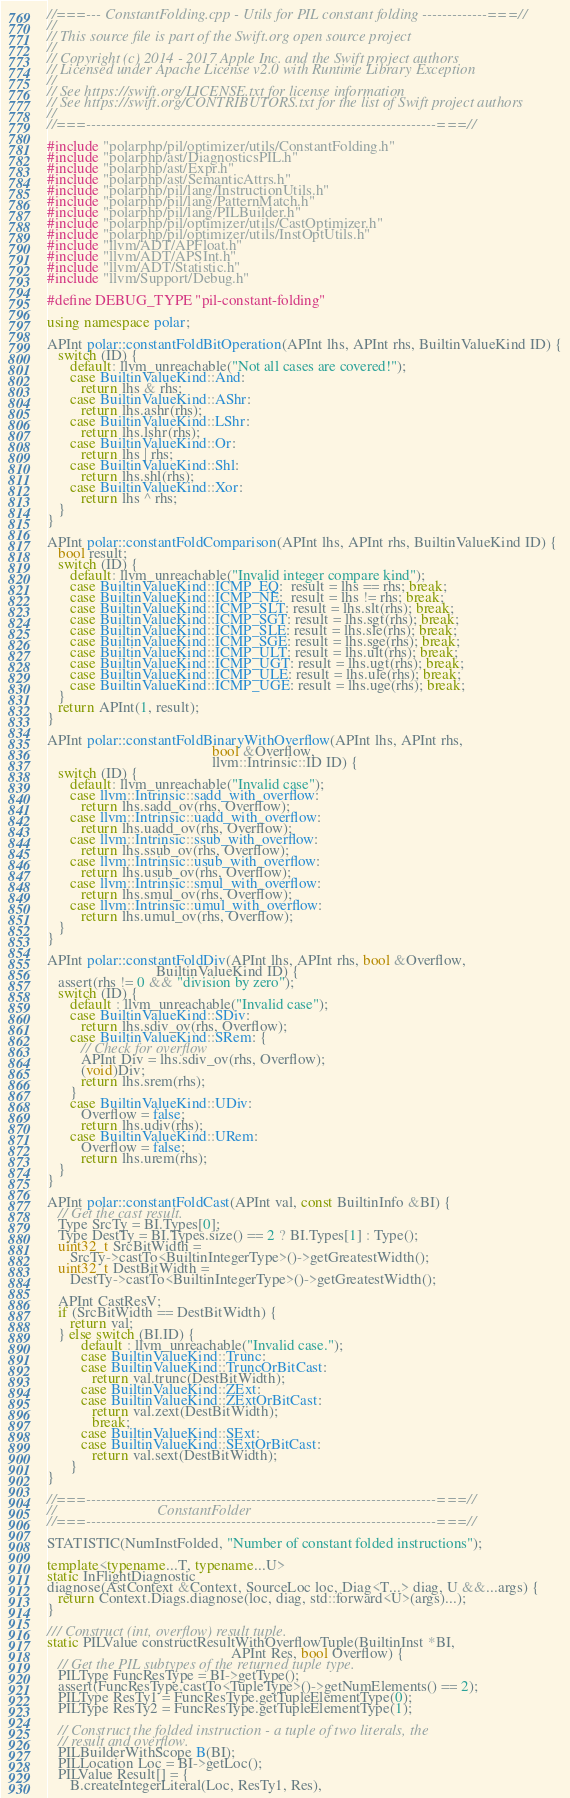<code> <loc_0><loc_0><loc_500><loc_500><_C++_>//===--- ConstantFolding.cpp - Utils for PIL constant folding -------------===//
//
// This source file is part of the Swift.org open source project
//
// Copyright (c) 2014 - 2017 Apple Inc. and the Swift project authors
// Licensed under Apache License v2.0 with Runtime Library Exception
//
// See https://swift.org/LICENSE.txt for license information
// See https://swift.org/CONTRIBUTORS.txt for the list of Swift project authors
//
//===----------------------------------------------------------------------===//

#include "polarphp/pil/optimizer/utils/ConstantFolding.h"
#include "polarphp/ast/DiagnosticsPIL.h"
#include "polarphp/ast/Expr.h"
#include "polarphp/ast/SemanticAttrs.h"
#include "polarphp/pil/lang/InstructionUtils.h"
#include "polarphp/pil/lang/PatternMatch.h"
#include "polarphp/pil/lang/PILBuilder.h"
#include "polarphp/pil/optimizer/utils/CastOptimizer.h"
#include "polarphp/pil/optimizer/utils/InstOptUtils.h"
#include "llvm/ADT/APFloat.h"
#include "llvm/ADT/APSInt.h"
#include "llvm/ADT/Statistic.h"
#include "llvm/Support/Debug.h"

#define DEBUG_TYPE "pil-constant-folding"

using namespace polar;

APInt polar::constantFoldBitOperation(APInt lhs, APInt rhs, BuiltinValueKind ID) {
   switch (ID) {
      default: llvm_unreachable("Not all cases are covered!");
      case BuiltinValueKind::And:
         return lhs & rhs;
      case BuiltinValueKind::AShr:
         return lhs.ashr(rhs);
      case BuiltinValueKind::LShr:
         return lhs.lshr(rhs);
      case BuiltinValueKind::Or:
         return lhs | rhs;
      case BuiltinValueKind::Shl:
         return lhs.shl(rhs);
      case BuiltinValueKind::Xor:
         return lhs ^ rhs;
   }
}

APInt polar::constantFoldComparison(APInt lhs, APInt rhs, BuiltinValueKind ID) {
   bool result;
   switch (ID) {
      default: llvm_unreachable("Invalid integer compare kind");
      case BuiltinValueKind::ICMP_EQ:  result = lhs == rhs; break;
      case BuiltinValueKind::ICMP_NE:  result = lhs != rhs; break;
      case BuiltinValueKind::ICMP_SLT: result = lhs.slt(rhs); break;
      case BuiltinValueKind::ICMP_SGT: result = lhs.sgt(rhs); break;
      case BuiltinValueKind::ICMP_SLE: result = lhs.sle(rhs); break;
      case BuiltinValueKind::ICMP_SGE: result = lhs.sge(rhs); break;
      case BuiltinValueKind::ICMP_ULT: result = lhs.ult(rhs); break;
      case BuiltinValueKind::ICMP_UGT: result = lhs.ugt(rhs); break;
      case BuiltinValueKind::ICMP_ULE: result = lhs.ule(rhs); break;
      case BuiltinValueKind::ICMP_UGE: result = lhs.uge(rhs); break;
   }
   return APInt(1, result);
}

APInt polar::constantFoldBinaryWithOverflow(APInt lhs, APInt rhs,
                                            bool &Overflow,
                                            llvm::Intrinsic::ID ID) {
   switch (ID) {
      default: llvm_unreachable("Invalid case");
      case llvm::Intrinsic::sadd_with_overflow:
         return lhs.sadd_ov(rhs, Overflow);
      case llvm::Intrinsic::uadd_with_overflow:
         return lhs.uadd_ov(rhs, Overflow);
      case llvm::Intrinsic::ssub_with_overflow:
         return lhs.ssub_ov(rhs, Overflow);
      case llvm::Intrinsic::usub_with_overflow:
         return lhs.usub_ov(rhs, Overflow);
      case llvm::Intrinsic::smul_with_overflow:
         return lhs.smul_ov(rhs, Overflow);
      case llvm::Intrinsic::umul_with_overflow:
         return lhs.umul_ov(rhs, Overflow);
   }
}

APInt polar::constantFoldDiv(APInt lhs, APInt rhs, bool &Overflow,
                             BuiltinValueKind ID) {
   assert(rhs != 0 && "division by zero");
   switch (ID) {
      default : llvm_unreachable("Invalid case");
      case BuiltinValueKind::SDiv:
         return lhs.sdiv_ov(rhs, Overflow);
      case BuiltinValueKind::SRem: {
         // Check for overflow
         APInt Div = lhs.sdiv_ov(rhs, Overflow);
         (void)Div;
         return lhs.srem(rhs);
      }
      case BuiltinValueKind::UDiv:
         Overflow = false;
         return lhs.udiv(rhs);
      case BuiltinValueKind::URem:
         Overflow = false;
         return lhs.urem(rhs);
   }
}

APInt polar::constantFoldCast(APInt val, const BuiltinInfo &BI) {
   // Get the cast result.
   Type SrcTy = BI.Types[0];
   Type DestTy = BI.Types.size() == 2 ? BI.Types[1] : Type();
   uint32_t SrcBitWidth =
      SrcTy->castTo<BuiltinIntegerType>()->getGreatestWidth();
   uint32_t DestBitWidth =
      DestTy->castTo<BuiltinIntegerType>()->getGreatestWidth();

   APInt CastResV;
   if (SrcBitWidth == DestBitWidth) {
      return val;
   } else switch (BI.ID) {
         default : llvm_unreachable("Invalid case.");
         case BuiltinValueKind::Trunc:
         case BuiltinValueKind::TruncOrBitCast:
            return val.trunc(DestBitWidth);
         case BuiltinValueKind::ZExt:
         case BuiltinValueKind::ZExtOrBitCast:
            return val.zext(DestBitWidth);
            break;
         case BuiltinValueKind::SExt:
         case BuiltinValueKind::SExtOrBitCast:
            return val.sext(DestBitWidth);
      }
}

//===----------------------------------------------------------------------===//
//                           ConstantFolder
//===----------------------------------------------------------------------===//

STATISTIC(NumInstFolded, "Number of constant folded instructions");

template<typename...T, typename...U>
static InFlightDiagnostic
diagnose(AstContext &Context, SourceLoc loc, Diag<T...> diag, U &&...args) {
   return Context.Diags.diagnose(loc, diag, std::forward<U>(args)...);
}

/// Construct (int, overflow) result tuple.
static PILValue constructResultWithOverflowTuple(BuiltinInst *BI,
                                                 APInt Res, bool Overflow) {
   // Get the PIL subtypes of the returned tuple type.
   PILType FuncResType = BI->getType();
   assert(FuncResType.castTo<TupleType>()->getNumElements() == 2);
   PILType ResTy1 = FuncResType.getTupleElementType(0);
   PILType ResTy2 = FuncResType.getTupleElementType(1);

   // Construct the folded instruction - a tuple of two literals, the
   // result and overflow.
   PILBuilderWithScope B(BI);
   PILLocation Loc = BI->getLoc();
   PILValue Result[] = {
      B.createIntegerLiteral(Loc, ResTy1, Res),</code> 